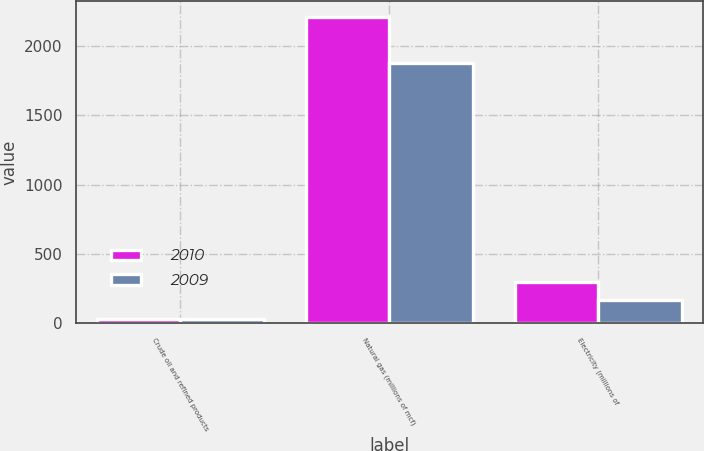Convert chart. <chart><loc_0><loc_0><loc_500><loc_500><stacked_bar_chart><ecel><fcel>Crude oil and refined products<fcel>Natural gas (millions of mcf)<fcel>Electricity (millions of<nl><fcel>2010<fcel>30<fcel>2210<fcel>301<nl><fcel>2009<fcel>34<fcel>1876<fcel>166<nl></chart> 